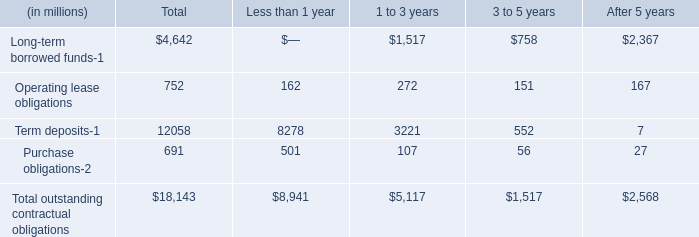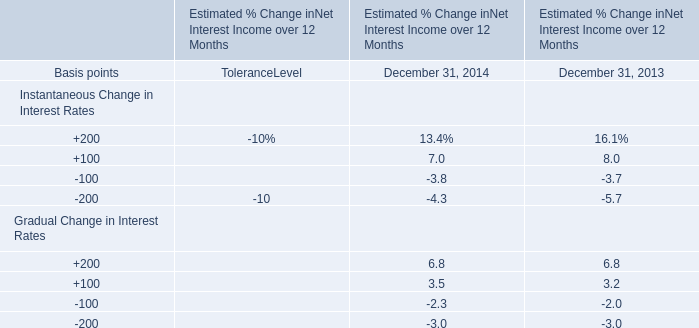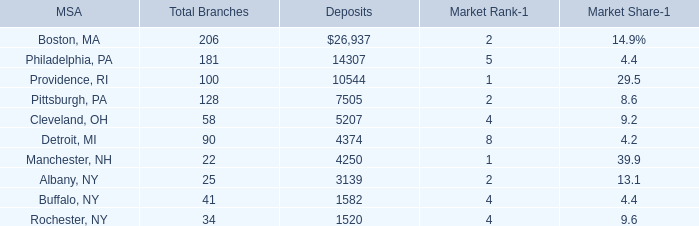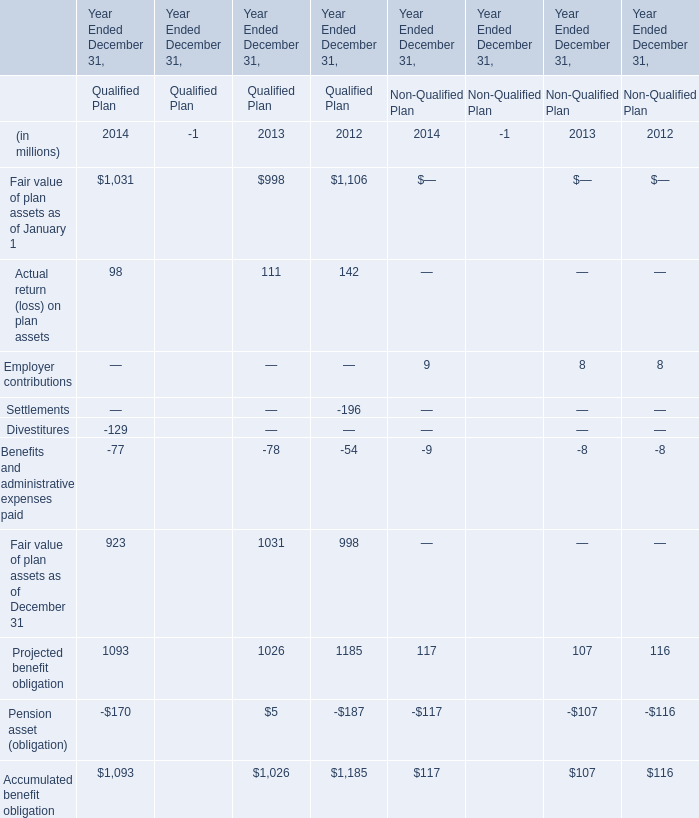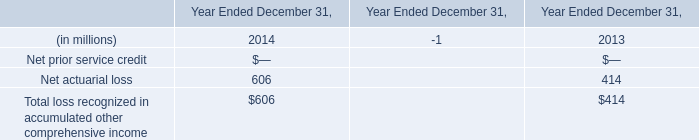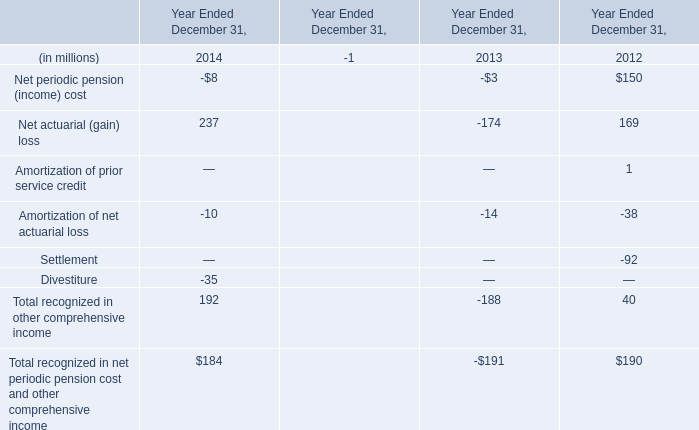What is the sum of Net periodic pension (income) cost,Amortization of net actuarial loss and DivestitureDivestiture in 2014 ? (in million) 
Computations: ((-8 - 10) - 35)
Answer: -53.0. 